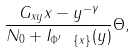Convert formula to latex. <formula><loc_0><loc_0><loc_500><loc_500>\frac { G _ { x y } \| x - y \| ^ { - \gamma } } { N _ { 0 } + I _ { \Phi ^ { \prime } \ \{ x \} } ( y ) } \Theta ,</formula> 